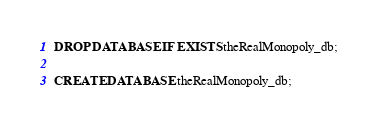<code> <loc_0><loc_0><loc_500><loc_500><_SQL_>DROP DATABASE IF EXISTS theRealMonopoly_db;

CREATE DATABASE theRealMonopoly_db;</code> 